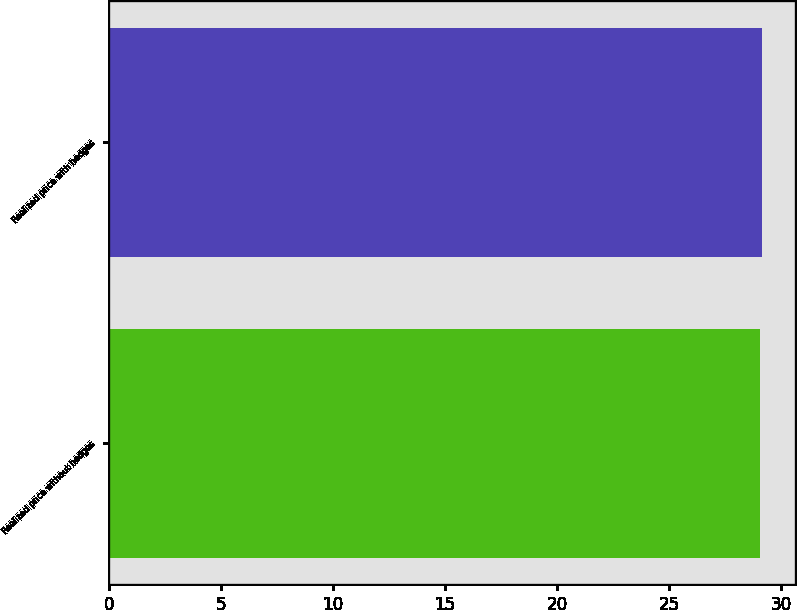Convert chart to OTSL. <chart><loc_0><loc_0><loc_500><loc_500><bar_chart><fcel>Realized price without hedges<fcel>Realized price with hedges<nl><fcel>29.05<fcel>29.15<nl></chart> 